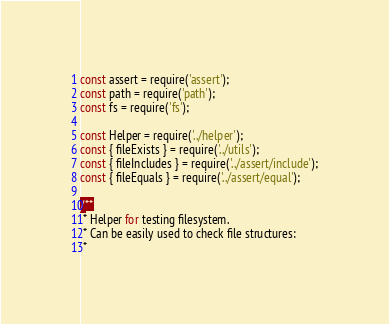<code> <loc_0><loc_0><loc_500><loc_500><_JavaScript_>const assert = require('assert');
const path = require('path');
const fs = require('fs');

const Helper = require('../helper');
const { fileExists } = require('../utils');
const { fileIncludes } = require('../assert/include');
const { fileEquals } = require('../assert/equal');

/**
 * Helper for testing filesystem.
 * Can be easily used to check file structures:
 *</code> 